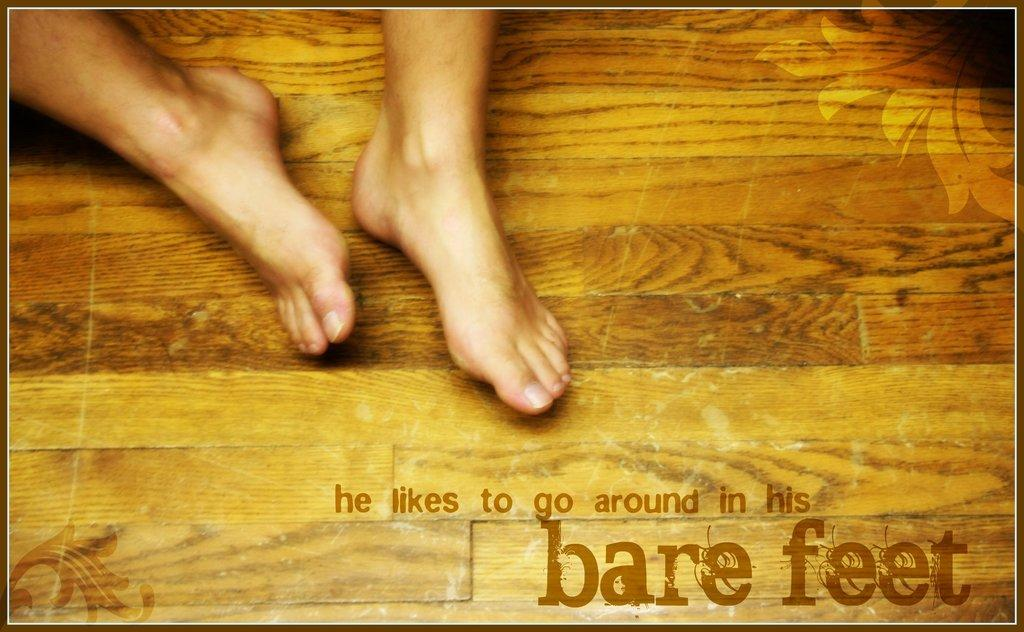<image>
Share a concise interpretation of the image provided. Person's foot on a wooden floor and the words "he likes to go around in bare feet" on the bottom. 